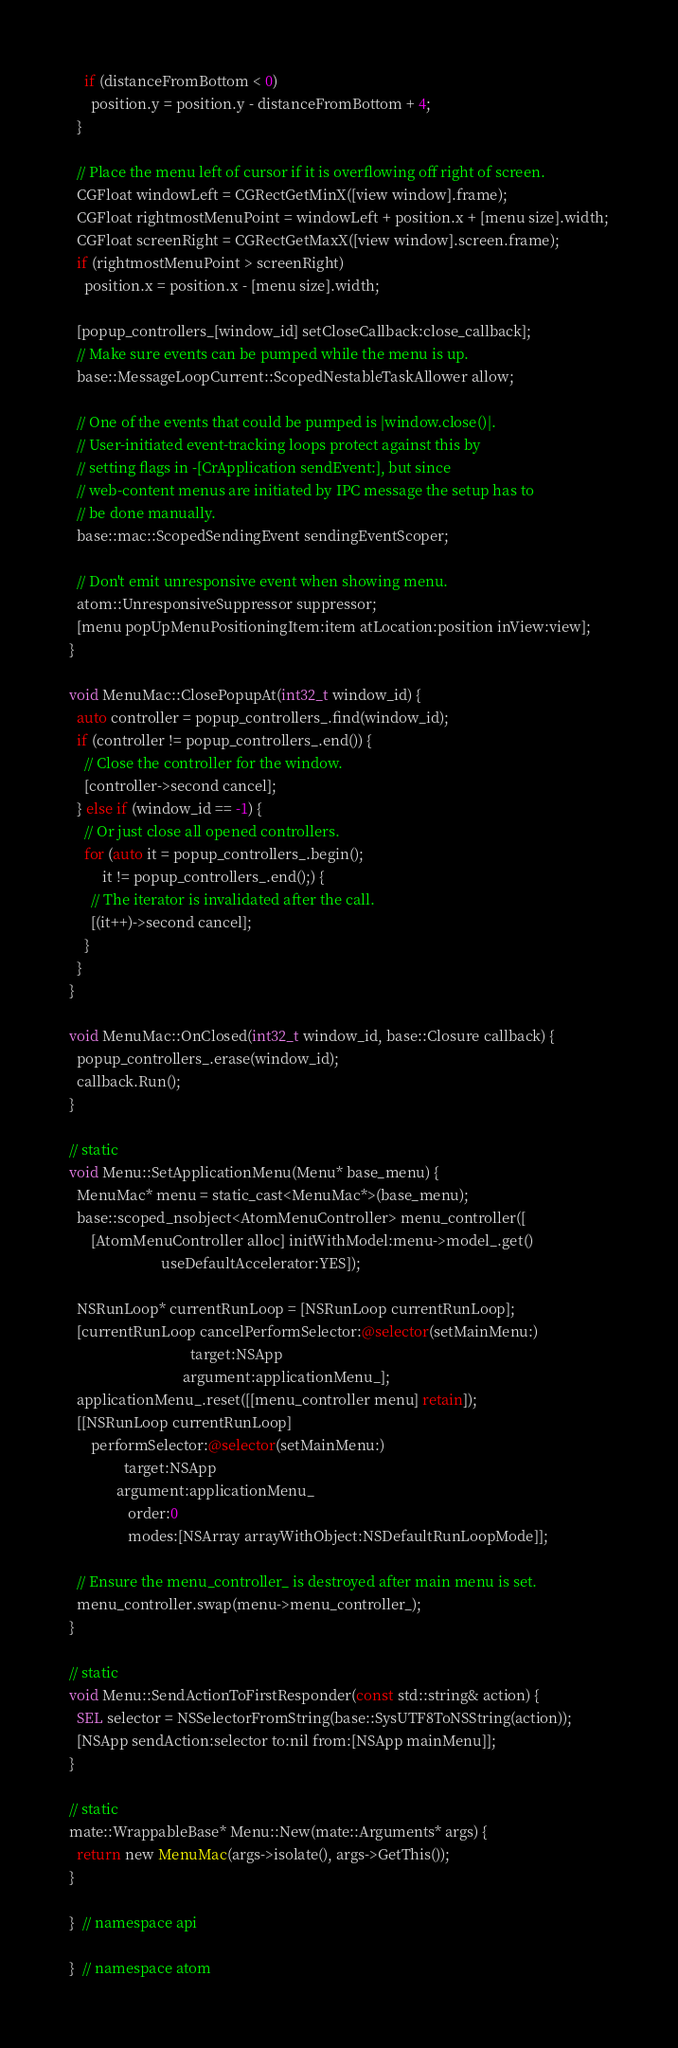Convert code to text. <code><loc_0><loc_0><loc_500><loc_500><_ObjectiveC_>    if (distanceFromBottom < 0)
      position.y = position.y - distanceFromBottom + 4;
  }

  // Place the menu left of cursor if it is overflowing off right of screen.
  CGFloat windowLeft = CGRectGetMinX([view window].frame);
  CGFloat rightmostMenuPoint = windowLeft + position.x + [menu size].width;
  CGFloat screenRight = CGRectGetMaxX([view window].screen.frame);
  if (rightmostMenuPoint > screenRight)
    position.x = position.x - [menu size].width;

  [popup_controllers_[window_id] setCloseCallback:close_callback];
  // Make sure events can be pumped while the menu is up.
  base::MessageLoopCurrent::ScopedNestableTaskAllower allow;

  // One of the events that could be pumped is |window.close()|.
  // User-initiated event-tracking loops protect against this by
  // setting flags in -[CrApplication sendEvent:], but since
  // web-content menus are initiated by IPC message the setup has to
  // be done manually.
  base::mac::ScopedSendingEvent sendingEventScoper;

  // Don't emit unresponsive event when showing menu.
  atom::UnresponsiveSuppressor suppressor;
  [menu popUpMenuPositioningItem:item atLocation:position inView:view];
}

void MenuMac::ClosePopupAt(int32_t window_id) {
  auto controller = popup_controllers_.find(window_id);
  if (controller != popup_controllers_.end()) {
    // Close the controller for the window.
    [controller->second cancel];
  } else if (window_id == -1) {
    // Or just close all opened controllers.
    for (auto it = popup_controllers_.begin();
         it != popup_controllers_.end();) {
      // The iterator is invalidated after the call.
      [(it++)->second cancel];
    }
  }
}

void MenuMac::OnClosed(int32_t window_id, base::Closure callback) {
  popup_controllers_.erase(window_id);
  callback.Run();
}

// static
void Menu::SetApplicationMenu(Menu* base_menu) {
  MenuMac* menu = static_cast<MenuMac*>(base_menu);
  base::scoped_nsobject<AtomMenuController> menu_controller([
      [AtomMenuController alloc] initWithModel:menu->model_.get()
                         useDefaultAccelerator:YES]);

  NSRunLoop* currentRunLoop = [NSRunLoop currentRunLoop];
  [currentRunLoop cancelPerformSelector:@selector(setMainMenu:)
                                 target:NSApp
                               argument:applicationMenu_];
  applicationMenu_.reset([[menu_controller menu] retain]);
  [[NSRunLoop currentRunLoop]
      performSelector:@selector(setMainMenu:)
               target:NSApp
             argument:applicationMenu_
                order:0
                modes:[NSArray arrayWithObject:NSDefaultRunLoopMode]];

  // Ensure the menu_controller_ is destroyed after main menu is set.
  menu_controller.swap(menu->menu_controller_);
}

// static
void Menu::SendActionToFirstResponder(const std::string& action) {
  SEL selector = NSSelectorFromString(base::SysUTF8ToNSString(action));
  [NSApp sendAction:selector to:nil from:[NSApp mainMenu]];
}

// static
mate::WrappableBase* Menu::New(mate::Arguments* args) {
  return new MenuMac(args->isolate(), args->GetThis());
}

}  // namespace api

}  // namespace atom
</code> 